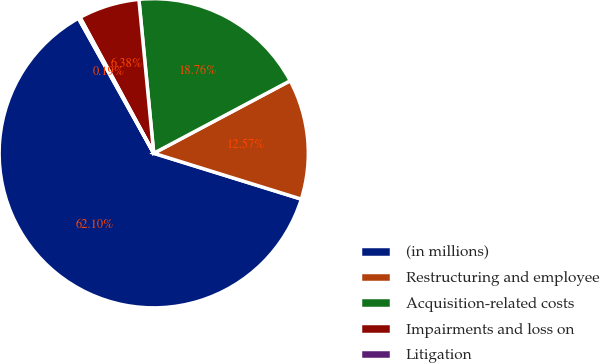<chart> <loc_0><loc_0><loc_500><loc_500><pie_chart><fcel>(in millions)<fcel>Restructuring and employee<fcel>Acquisition-related costs<fcel>Impairments and loss on<fcel>Litigation<nl><fcel>62.11%<fcel>12.57%<fcel>18.76%<fcel>6.38%<fcel>0.19%<nl></chart> 